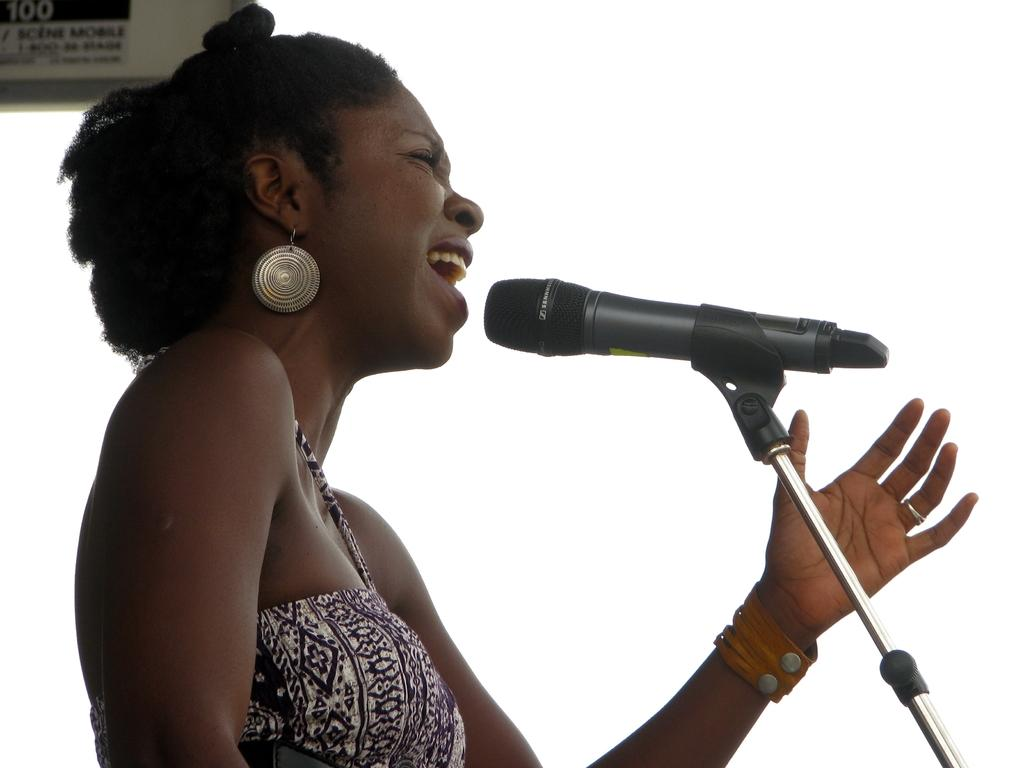Who is the main subject in the image? There is a woman in the image. What is the woman wearing? The woman is wearing earrings and a dress. What is the woman doing in the image? The woman is standing before a microphone stand. What is present in the top left corner of the image? There is a board in the top left corner of the image. What can be seen in the background of the image? The sky is visible in the background of the image. What type of donkey can be seen standing next to the woman in the image? There is no donkey present in the image; the woman is standing before a microphone stand. What color is the spot on the woman's dress in the image? The provided facts do not mention any spots on the woman's dress, so we cannot determine the color of a spot. 